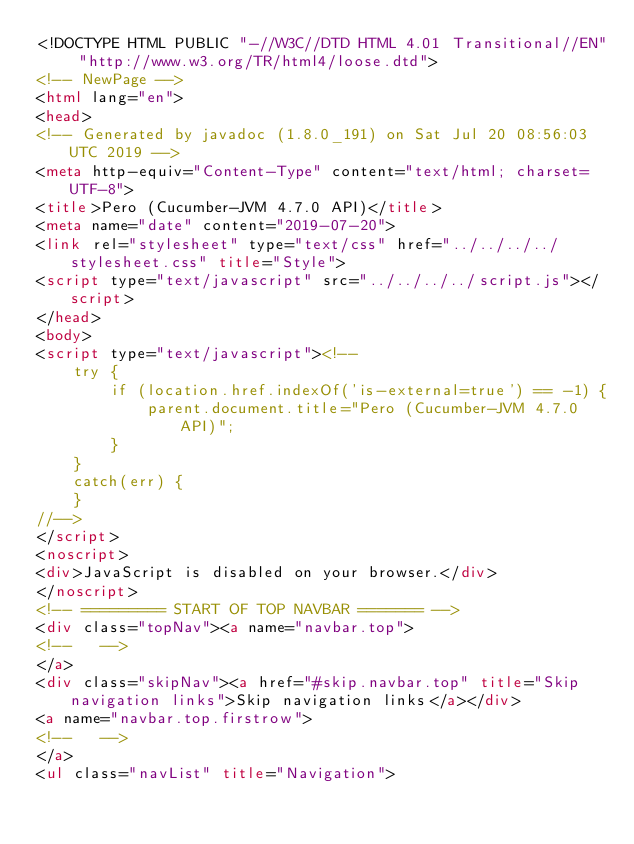Convert code to text. <code><loc_0><loc_0><loc_500><loc_500><_HTML_><!DOCTYPE HTML PUBLIC "-//W3C//DTD HTML 4.01 Transitional//EN" "http://www.w3.org/TR/html4/loose.dtd">
<!-- NewPage -->
<html lang="en">
<head>
<!-- Generated by javadoc (1.8.0_191) on Sat Jul 20 08:56:03 UTC 2019 -->
<meta http-equiv="Content-Type" content="text/html; charset=UTF-8">
<title>Pero (Cucumber-JVM 4.7.0 API)</title>
<meta name="date" content="2019-07-20">
<link rel="stylesheet" type="text/css" href="../../../../stylesheet.css" title="Style">
<script type="text/javascript" src="../../../../script.js"></script>
</head>
<body>
<script type="text/javascript"><!--
    try {
        if (location.href.indexOf('is-external=true') == -1) {
            parent.document.title="Pero (Cucumber-JVM 4.7.0 API)";
        }
    }
    catch(err) {
    }
//-->
</script>
<noscript>
<div>JavaScript is disabled on your browser.</div>
</noscript>
<!-- ========= START OF TOP NAVBAR ======= -->
<div class="topNav"><a name="navbar.top">
<!--   -->
</a>
<div class="skipNav"><a href="#skip.navbar.top" title="Skip navigation links">Skip navigation links</a></div>
<a name="navbar.top.firstrow">
<!--   -->
</a>
<ul class="navList" title="Navigation"></code> 